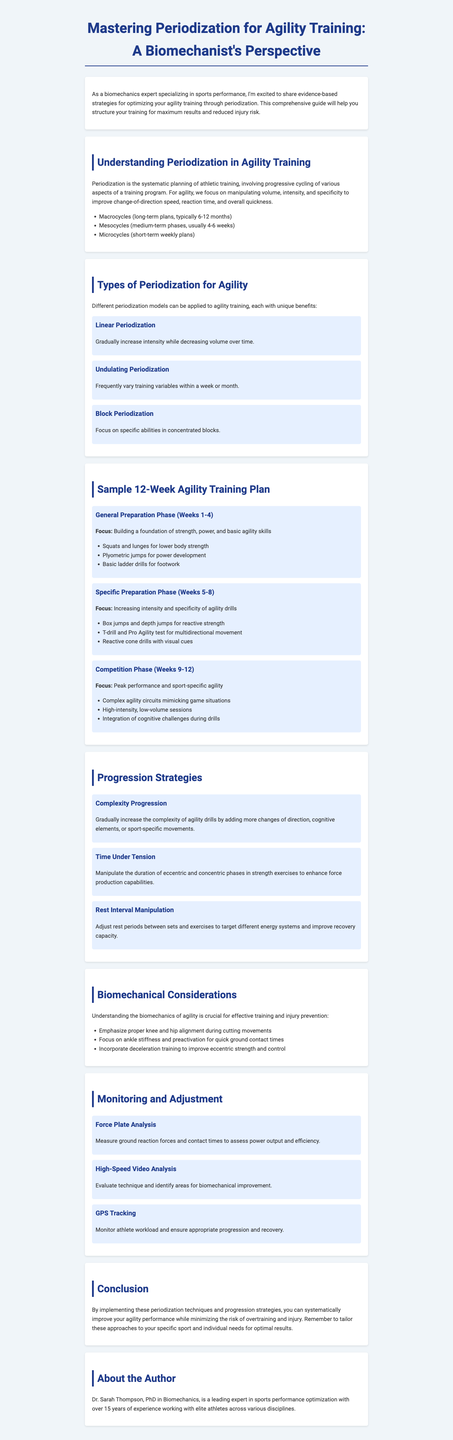What is the title of the newsletter? The title is provided at the beginning of the document, which explicitly states "Mastering Periodization for Agility Training: A Biomechanist's Perspective."
Answer: Mastering Periodization for Agility Training: A Biomechanist's Perspective How many weeks are in the sample agility training plan? The sample training plan consists of three phases, each covering a specific number of weeks totaling 12 weeks.
Answer: 12 weeks What type of periodization focuses on specific abilities in concentrated blocks? The document outlines various periodization models, and Block Periodization is noted for this specific focus.
Answer: Block Periodization What is an example of a tool used for monitoring in agility training? The document lists several tools, and one mentioned for assessment is Force Plate Analysis.
Answer: Force Plate Analysis What is the focus of the Specific Preparation Phase in the training plan? The document specifies that this phase focuses on increasing intensity and specificity of agility drills.
Answer: Increasing intensity and specificity of agility drills What does 'Time Under Tension' refer to in progression strategies? This strategy refers to manipulating the duration of eccentric and concentric phases in strength exercises.
Answer: Duration of eccentric and concentric phases What is one key point regarding biomechanics in agility training? The document highlights that emphasis on proper knee and hip alignment during cutting movements is crucial.
Answer: Proper knee and hip alignment Who is the author of the newsletter? The author information is provided towards the end of the document, which mentions their full name and credentials.
Answer: Dr. Sarah Thompson 